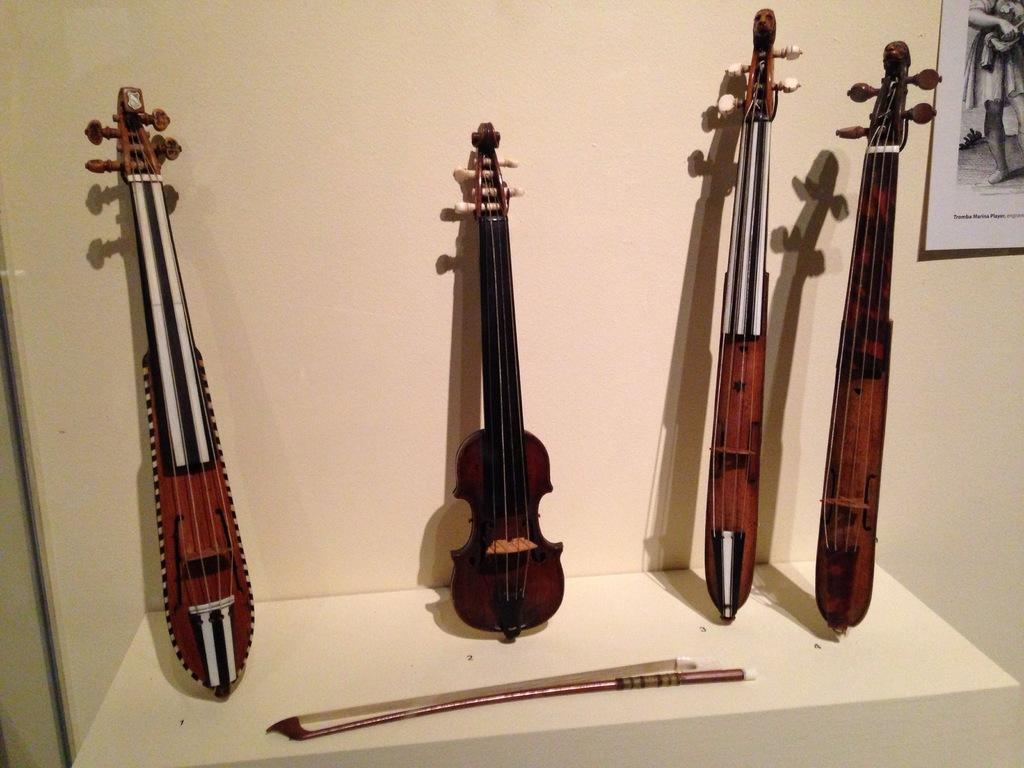What is the main object in the image? There is a violin in the image. What else can be seen on the table with the violin? There are other musical instruments on the table. Where is the table located in the image? The table is in the foreground of the image. What is visible on the wall in the background of the image? There is a poster on the wall in the background of the image. Can you see any hands holding the violin in the image? There are no hands visible in the image, as the violin is likely resting on the table or a stand. 